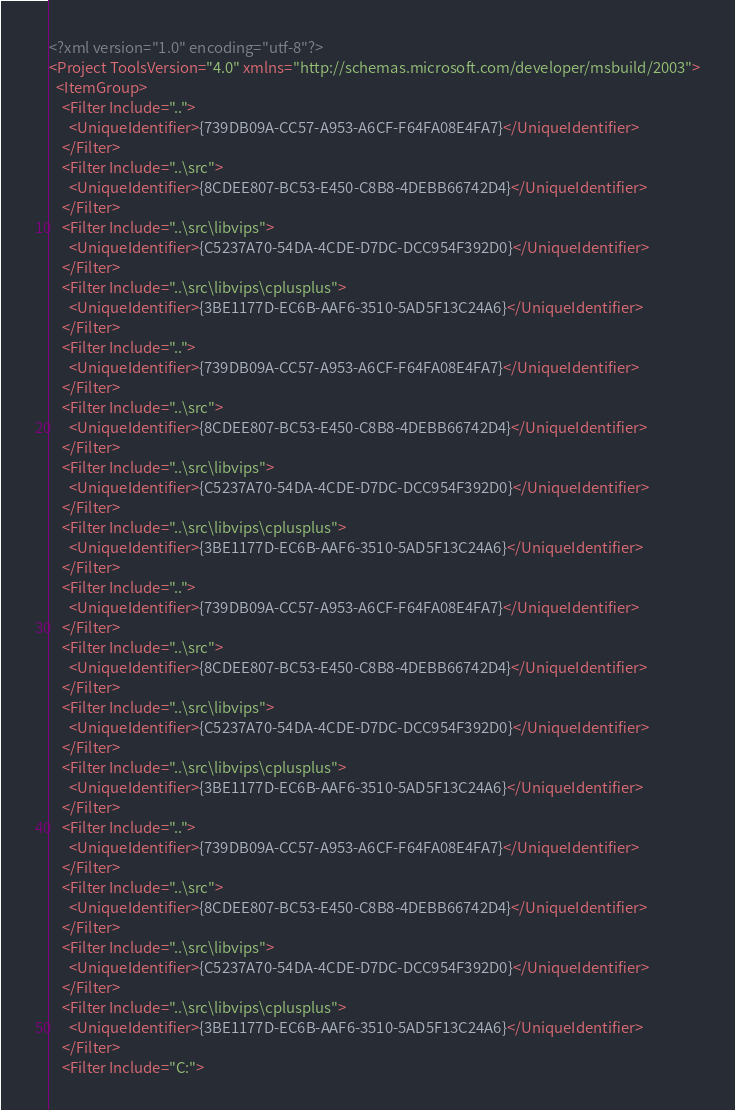<code> <loc_0><loc_0><loc_500><loc_500><_XML_><?xml version="1.0" encoding="utf-8"?>
<Project ToolsVersion="4.0" xmlns="http://schemas.microsoft.com/developer/msbuild/2003">
  <ItemGroup>
    <Filter Include="..">
      <UniqueIdentifier>{739DB09A-CC57-A953-A6CF-F64FA08E4FA7}</UniqueIdentifier>
    </Filter>
    <Filter Include="..\src">
      <UniqueIdentifier>{8CDEE807-BC53-E450-C8B8-4DEBB66742D4}</UniqueIdentifier>
    </Filter>
    <Filter Include="..\src\libvips">
      <UniqueIdentifier>{C5237A70-54DA-4CDE-D7DC-DCC954F392D0}</UniqueIdentifier>
    </Filter>
    <Filter Include="..\src\libvips\cplusplus">
      <UniqueIdentifier>{3BE1177D-EC6B-AAF6-3510-5AD5F13C24A6}</UniqueIdentifier>
    </Filter>
    <Filter Include="..">
      <UniqueIdentifier>{739DB09A-CC57-A953-A6CF-F64FA08E4FA7}</UniqueIdentifier>
    </Filter>
    <Filter Include="..\src">
      <UniqueIdentifier>{8CDEE807-BC53-E450-C8B8-4DEBB66742D4}</UniqueIdentifier>
    </Filter>
    <Filter Include="..\src\libvips">
      <UniqueIdentifier>{C5237A70-54DA-4CDE-D7DC-DCC954F392D0}</UniqueIdentifier>
    </Filter>
    <Filter Include="..\src\libvips\cplusplus">
      <UniqueIdentifier>{3BE1177D-EC6B-AAF6-3510-5AD5F13C24A6}</UniqueIdentifier>
    </Filter>
    <Filter Include="..">
      <UniqueIdentifier>{739DB09A-CC57-A953-A6CF-F64FA08E4FA7}</UniqueIdentifier>
    </Filter>
    <Filter Include="..\src">
      <UniqueIdentifier>{8CDEE807-BC53-E450-C8B8-4DEBB66742D4}</UniqueIdentifier>
    </Filter>
    <Filter Include="..\src\libvips">
      <UniqueIdentifier>{C5237A70-54DA-4CDE-D7DC-DCC954F392D0}</UniqueIdentifier>
    </Filter>
    <Filter Include="..\src\libvips\cplusplus">
      <UniqueIdentifier>{3BE1177D-EC6B-AAF6-3510-5AD5F13C24A6}</UniqueIdentifier>
    </Filter>
    <Filter Include="..">
      <UniqueIdentifier>{739DB09A-CC57-A953-A6CF-F64FA08E4FA7}</UniqueIdentifier>
    </Filter>
    <Filter Include="..\src">
      <UniqueIdentifier>{8CDEE807-BC53-E450-C8B8-4DEBB66742D4}</UniqueIdentifier>
    </Filter>
    <Filter Include="..\src\libvips">
      <UniqueIdentifier>{C5237A70-54DA-4CDE-D7DC-DCC954F392D0}</UniqueIdentifier>
    </Filter>
    <Filter Include="..\src\libvips\cplusplus">
      <UniqueIdentifier>{3BE1177D-EC6B-AAF6-3510-5AD5F13C24A6}</UniqueIdentifier>
    </Filter>
    <Filter Include="C:"></code> 